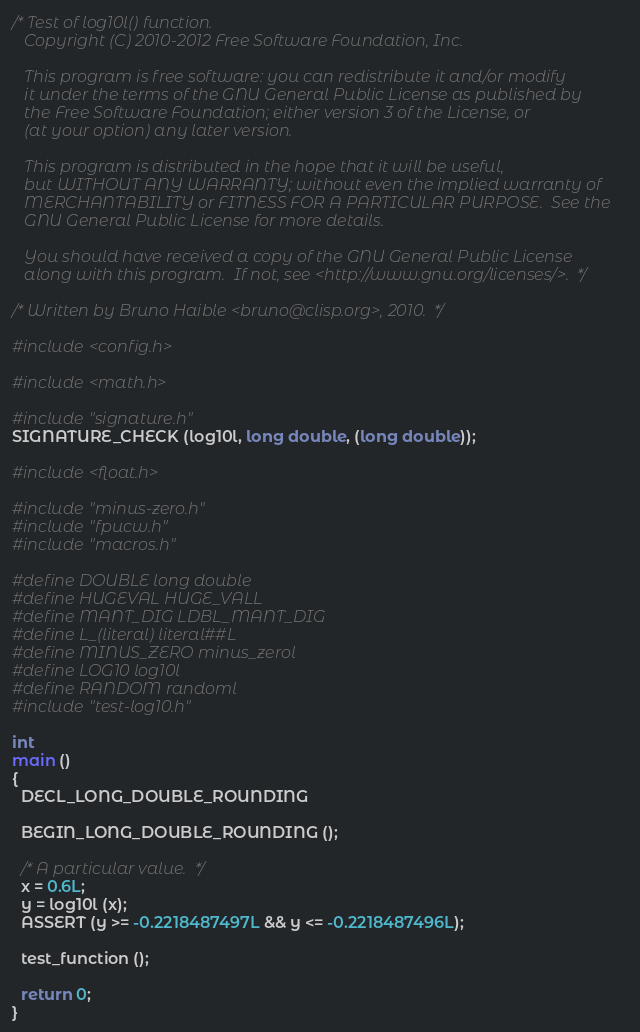<code> <loc_0><loc_0><loc_500><loc_500><_C_>/* Test of log10l() function.
   Copyright (C) 2010-2012 Free Software Foundation, Inc.

   This program is free software: you can redistribute it and/or modify
   it under the terms of the GNU General Public License as published by
   the Free Software Foundation; either version 3 of the License, or
   (at your option) any later version.

   This program is distributed in the hope that it will be useful,
   but WITHOUT ANY WARRANTY; without even the implied warranty of
   MERCHANTABILITY or FITNESS FOR A PARTICULAR PURPOSE.  See the
   GNU General Public License for more details.

   You should have received a copy of the GNU General Public License
   along with this program.  If not, see <http://www.gnu.org/licenses/>.  */

/* Written by Bruno Haible <bruno@clisp.org>, 2010.  */

#include <config.h>

#include <math.h>

#include "signature.h"
SIGNATURE_CHECK (log10l, long double, (long double));

#include <float.h>

#include "minus-zero.h"
#include "fpucw.h"
#include "macros.h"

#define DOUBLE long double
#define HUGEVAL HUGE_VALL
#define MANT_DIG LDBL_MANT_DIG
#define L_(literal) literal##L
#define MINUS_ZERO minus_zerol
#define LOG10 log10l
#define RANDOM randoml
#include "test-log10.h"

int
main ()
{
  DECL_LONG_DOUBLE_ROUNDING

  BEGIN_LONG_DOUBLE_ROUNDING ();

  /* A particular value.  */
  x = 0.6L;
  y = log10l (x);
  ASSERT (y >= -0.2218487497L && y <= -0.2218487496L);

  test_function ();

  return 0;
}
</code> 